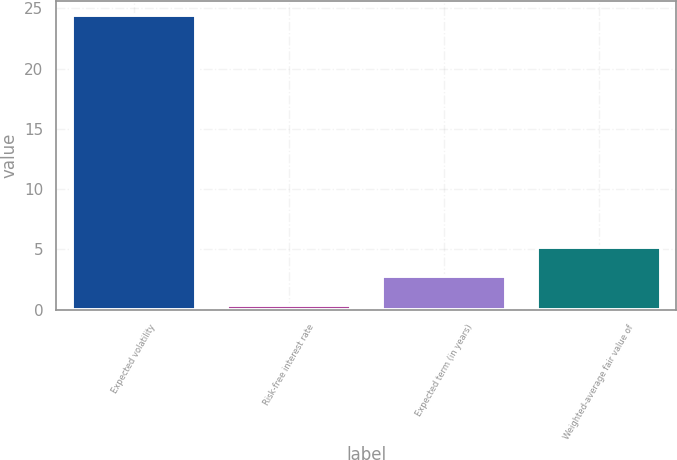Convert chart. <chart><loc_0><loc_0><loc_500><loc_500><bar_chart><fcel>Expected volatility<fcel>Risk-free interest rate<fcel>Expected term (in years)<fcel>Weighted-average fair value of<nl><fcel>24.4<fcel>0.43<fcel>2.83<fcel>5.23<nl></chart> 